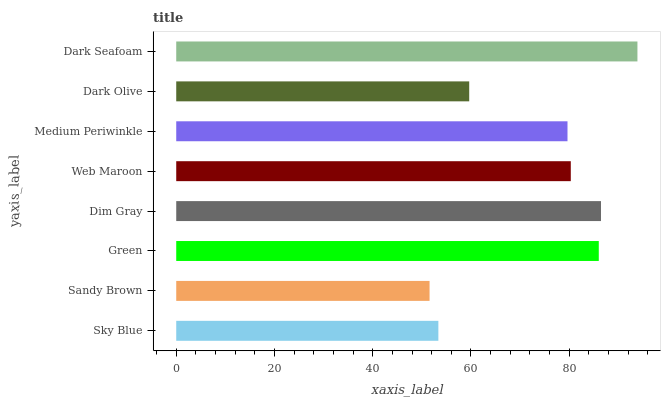Is Sandy Brown the minimum?
Answer yes or no. Yes. Is Dark Seafoam the maximum?
Answer yes or no. Yes. Is Green the minimum?
Answer yes or no. No. Is Green the maximum?
Answer yes or no. No. Is Green greater than Sandy Brown?
Answer yes or no. Yes. Is Sandy Brown less than Green?
Answer yes or no. Yes. Is Sandy Brown greater than Green?
Answer yes or no. No. Is Green less than Sandy Brown?
Answer yes or no. No. Is Web Maroon the high median?
Answer yes or no. Yes. Is Medium Periwinkle the low median?
Answer yes or no. Yes. Is Dark Seafoam the high median?
Answer yes or no. No. Is Web Maroon the low median?
Answer yes or no. No. 